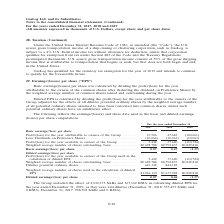According to Gaslog's financial document, How was basic earnings/(losses) per share calculated? By dividing the profit/(loss) for the year attributable to the owners of the common shares after deducting the dividend on Preference Shares by the weighted average number of common shares issued and outstanding during the year.. The document states: "Basic earnings/(losses) per share was calculated by dividing the profit/(loss) for the year attributable to the owners of the common shares after dedu..." Also, In which years was the earnings/(losses) per share recorded for? The document contains multiple relevant values: 2017, 2018, 2019. From the document: "For the year ended December 31, 2017 2018 2019 For the year ended December 31, 2017 2018 2019 For the year ended December 31, 2017 2018 2019..." Also, How was diluted EPS calculated? Diluted EPS is calculated by dividing the profit/(loss) for the year attributable to the owners of the Group adjusted for the effects of all dilutive potential ordinary shares by the weighted average number of all potential ordinary shares assumed to have been converted into common shares, unless such potential ordinary shares have an antidilutive effect.. The document states: "Diluted EPS is calculated by dividing the profit/(loss) for the year attributable to the owners of the Group adjusted for the effects of all dilutive ..." Additionally, Which year was the basic earnings per share the highest? According to the financial document, 2018. The relevant text states: "For the year ended December 31, 2017 2018 2019..." Also, can you calculate: What was the change in basic EPS from 2018 to 2019? Based on the calculation: (1.37) - 0.47 , the result is -1.84. This is based on the information: "Basic earnings/(loss) per share . 0.07 0.47 (1.37) Basic earnings/(loss) per share . 0.07 0.47 (1.37)..." The key data points involved are: 0.47, 1.37. Also, can you calculate: What was the percentage change in diluted EPS from 2017 to 2018? To answer this question, I need to perform calculations using the financial data. The calculation is: (0.46 - 0.07)/0.07 , which equals 557.14 (percentage). This is based on the information: "Diluted earnings/(loss) per share . 0.07 0.46 (1.37) Diluted earnings/(loss) per share . 0.07 0.46 (1.37)..." The key data points involved are: 0.07, 0.46. 